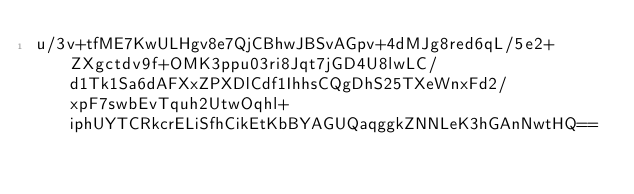<code> <loc_0><loc_0><loc_500><loc_500><_SML_>u/3v+tfME7KwULHgv8e7QjCBhwJBSvAGpv+4dMJg8red6qL/5e2+ZXgctdv9f+OMK3ppu03ri8Jqt7jGD4U8lwLC/d1Tk1Sa6dAFXxZPXDlCdf1IhhsCQgDhS25TXeWnxFd2/xpF7swbEvTquh2UtwOqhl+iphUYTCRkcrELiSfhCikEtKbBYAGUQaqggkZNNLeK3hGAnNwtHQ==</code> 